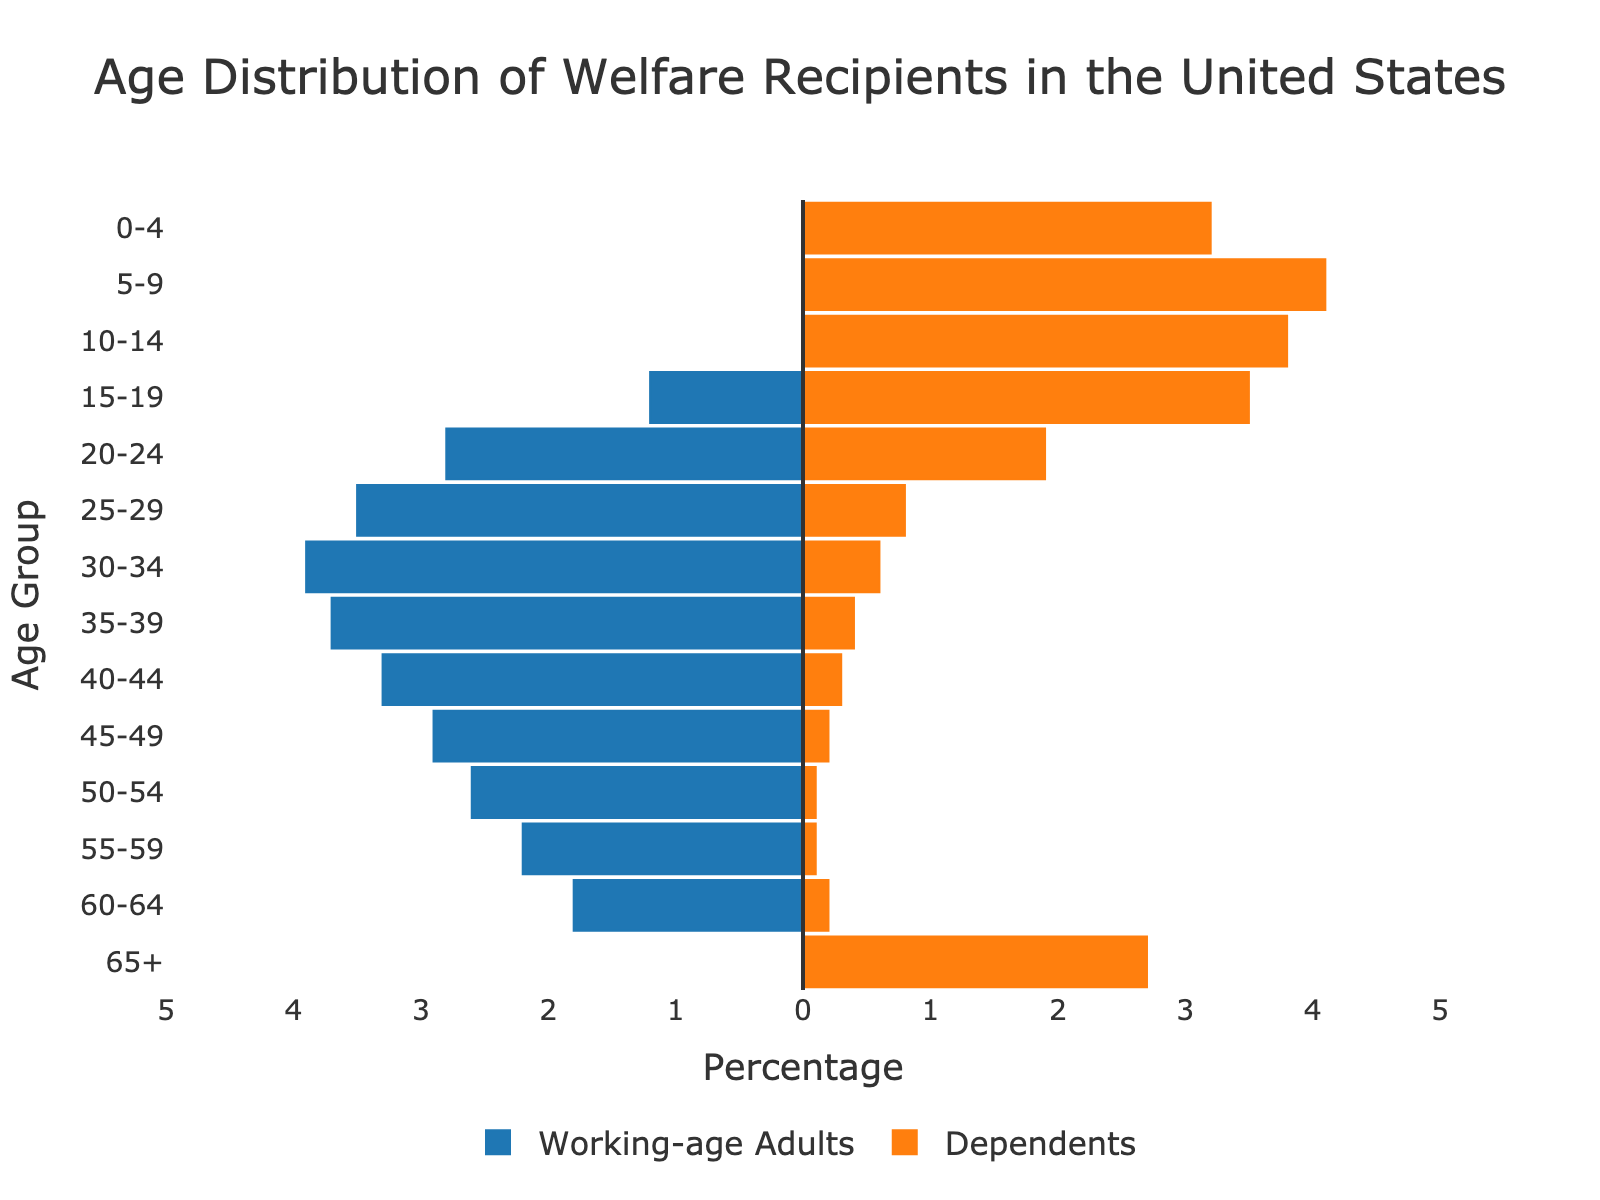What is the title of the figure? The title is located at the top center of the figure and reads "Age Distribution of Welfare Recipients in the United States."
Answer: Age Distribution of Welfare Recipients in the United States What age group has the highest percentage of dependents? The age group with the highest percentage of dependents can be identified by examining the lengths of the orange bars. The longest orange bar corresponds to the age group 5-9, which has 4.1%.
Answer: 5-9 Which age group has the highest percentage of working-age adults receiving welfare? To determine this, look at the lengths of the blue bars. The age group with the longest blue bar is 30-34 with 3.9%.
Answer: 30-34 Compare the percentage of welfare recipients in the age group 15-19 between working-age adults and dependents. For the age group 15-19, find the lengths of both the orange and blue bars. The blue bar (working-age adults) is at 1.2%, while the orange bar (dependents) is at 3.5%. By comparing, 3.5% is greater than 1.2%.
Answer: Dependents have a higher percentage (3.5% vs 1.2%) What is the percentage difference in welfare recipients between the age groups 20-24 and 25-29 for working-age adults? Identify the percentages for 20-24 (2.8%) and 25-29 (3.5%) by examining the lengths of the blue bars. Calculate the difference: 3.5% - 2.8% = 0.7%.
Answer: 0.7% In which age group do dependents show the smallest percentage? Locate the age group with the shortest orange bar. The smallest percentage for dependents is 0.1% for ages 50-54 and 55-59.
Answer: 50-54 and 55-59 Are there any age groups where the percentage of working-age adults and dependents is equal? To find equal percentages, check both bars for each age group. No age group shows equal percentages between working-age adults and dependents.
Answer: No How does the percentage of dependents in age group 0-4 compare to those aged 65+? Locate the orange bars for ages 0-4 (3.2%) and 65+ (2.7%). Comparing these two, 3.2% is greater than 2.7%.
Answer: 0-4 has a higher percentage (3.2% vs 2.7%) What is the combined percentage of welfare recipients aged 10-14? Add the percentages of dependents (3.8%) and working-age adults (0%). The combined percentage is 3.8%.
Answer: 3.8% Between the age groups 40-44 and 45-49, which has a higher total percentage of welfare recipients? Sum the percentages for both age groups by adding the working-age adults and dependents. For 40-44: 3.3% + 0.3% = 3.6%. For 45-49: 2.9% + 0.2% = 3.1%. 40-44 has a higher total percentage.
Answer: 40-44 (3.6% vs 3.1%) 